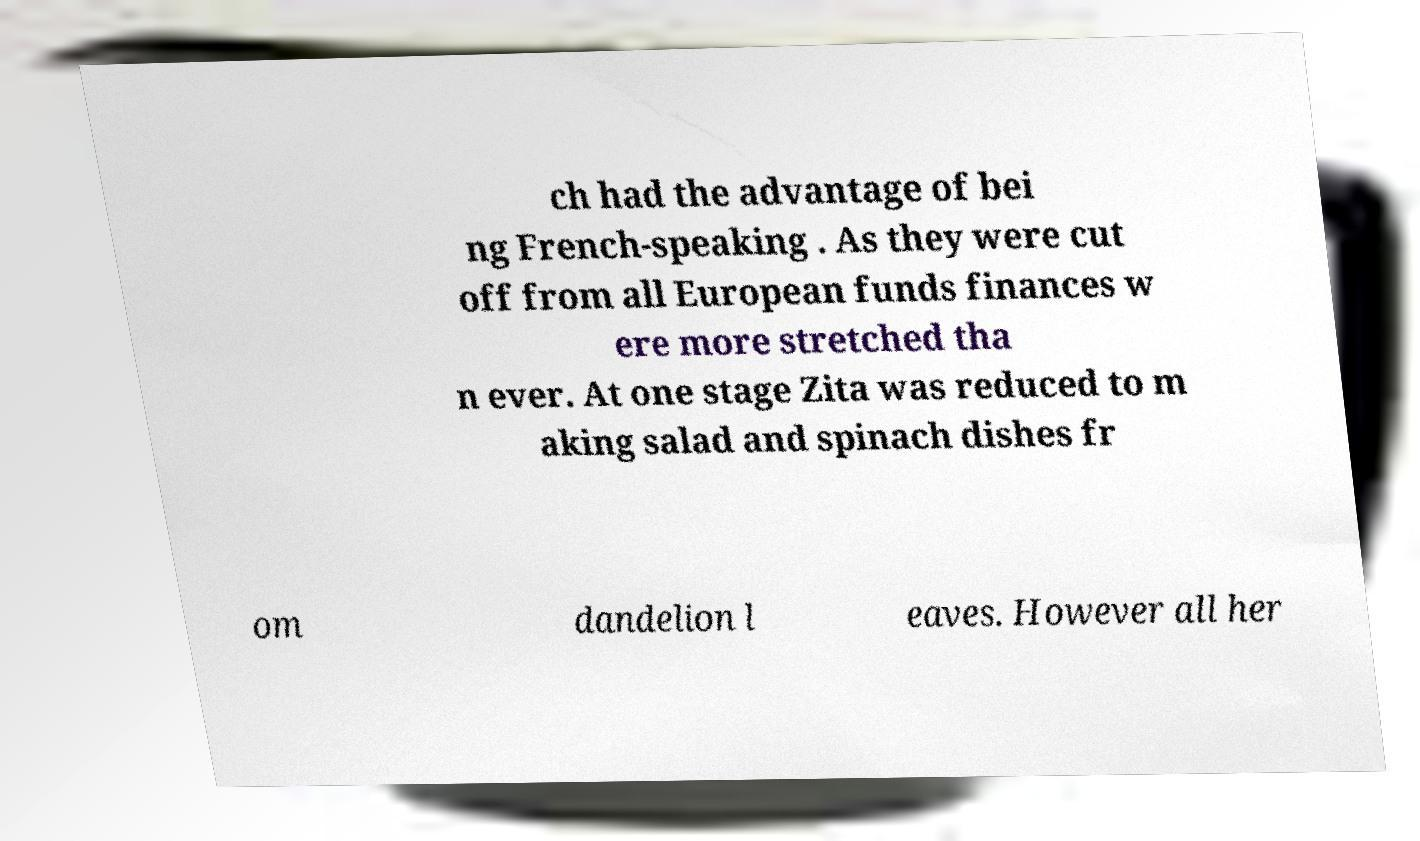Can you read and provide the text displayed in the image?This photo seems to have some interesting text. Can you extract and type it out for me? ch had the advantage of bei ng French-speaking . As they were cut off from all European funds finances w ere more stretched tha n ever. At one stage Zita was reduced to m aking salad and spinach dishes fr om dandelion l eaves. However all her 